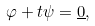Convert formula to latex. <formula><loc_0><loc_0><loc_500><loc_500>\varphi + t \psi = \underline { 0 } ,</formula> 